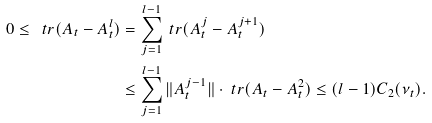<formula> <loc_0><loc_0><loc_500><loc_500>0 \leq \ t r ( A _ { t } - A _ { t } ^ { l } ) & = \sum _ { j = 1 } ^ { l - 1 } \ t r ( A _ { t } ^ { j } - A _ { t } ^ { j + 1 } ) \\ & \leq \sum _ { j = 1 } ^ { l - 1 } \| A _ { t } ^ { j - 1 } \| \cdot \ t r ( A _ { t } - A _ { t } ^ { 2 } ) \leq ( l - 1 ) C _ { 2 } ( \nu _ { t } ) .</formula> 